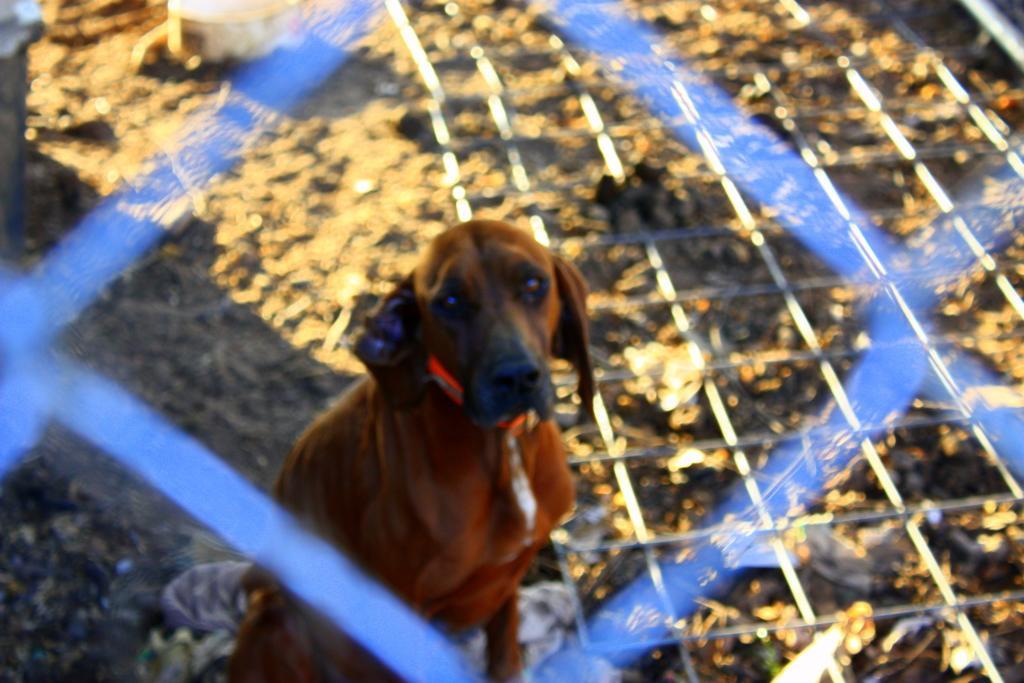Describe this image in one or two sentences. In the center of the image we can see a dog. We can also see a fence and a container on the ground. 